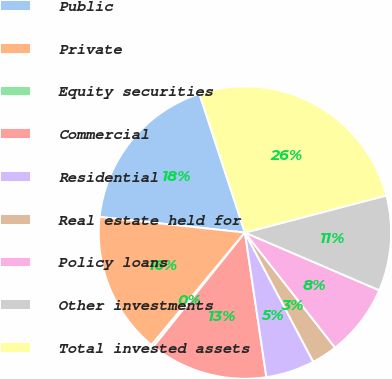<chart> <loc_0><loc_0><loc_500><loc_500><pie_chart><fcel>Public<fcel>Private<fcel>Equity securities<fcel>Commercial<fcel>Residential<fcel>Real estate held for<fcel>Policy loans<fcel>Other investments<fcel>Total invested assets<nl><fcel>18.25%<fcel>15.68%<fcel>0.26%<fcel>13.11%<fcel>5.4%<fcel>2.83%<fcel>7.97%<fcel>10.54%<fcel>25.96%<nl></chart> 